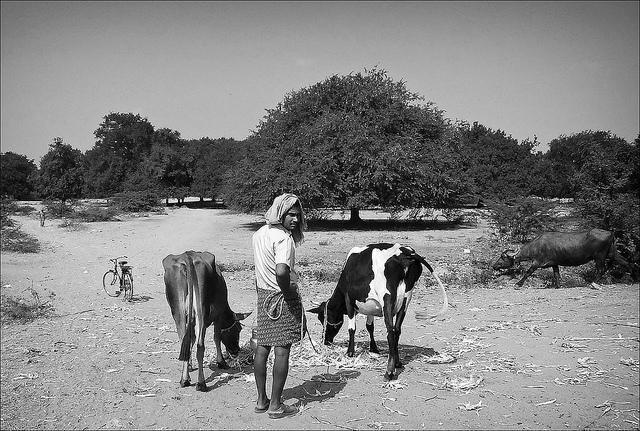How many legs are easily visible for the animal on the man's left?
Give a very brief answer. 3. How many cows?
Give a very brief answer. 2. How many cows are in the photo?
Give a very brief answer. 3. How many birds are flying in the picture?
Give a very brief answer. 0. 